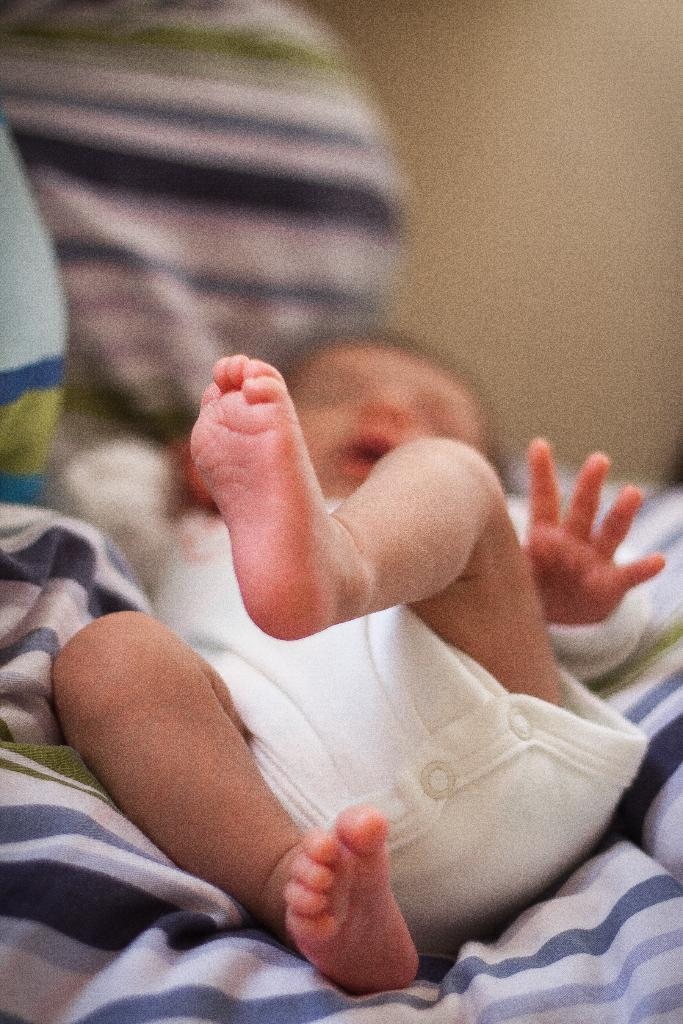What is the main subject of the image? There is a baby in the image. What is the baby wearing? The baby is wearing a white dress. Where is the baby located in the image? The baby is laying on a bed sheet. What can be seen in the background of the image? There is a wall in the background of the image. What type of birds can be seen flying in the image? There are no birds visible in the image; it features a baby laying on a bed sheet with a wall in the background. 